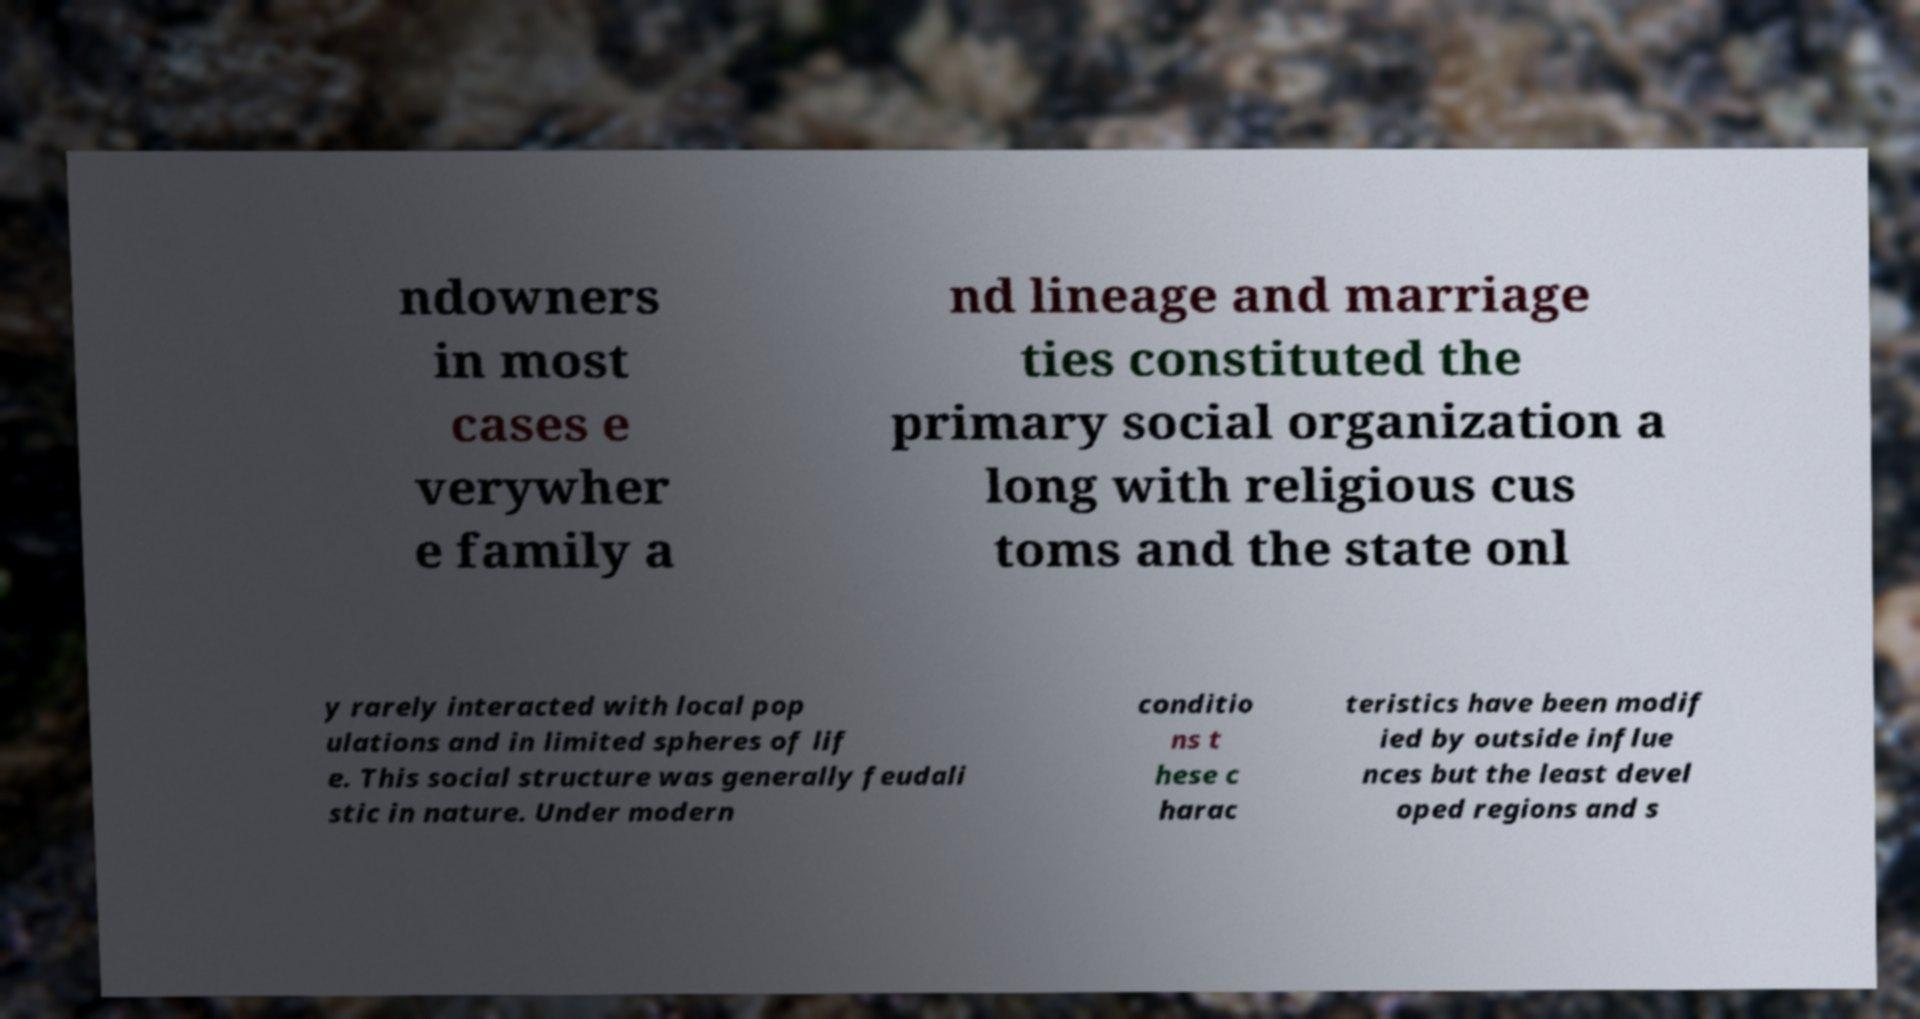Please identify and transcribe the text found in this image. ndowners in most cases e verywher e family a nd lineage and marriage ties constituted the primary social organization a long with religious cus toms and the state onl y rarely interacted with local pop ulations and in limited spheres of lif e. This social structure was generally feudali stic in nature. Under modern conditio ns t hese c harac teristics have been modif ied by outside influe nces but the least devel oped regions and s 